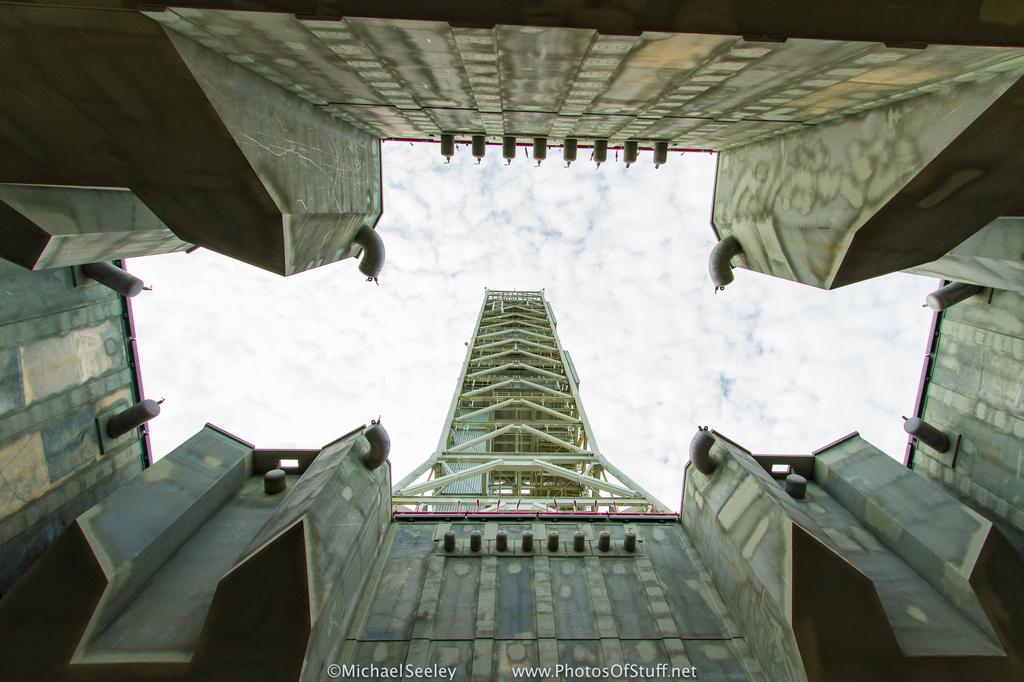What type of buildings can be seen in the image? There are skyscrapers in the image. What structures are present on top of the buildings? There are chimneys in the image. What type of fencing is visible in the image? There are iron grills in the image. What is visible in the background of the image? The sky is visible in the image, and there are clouds in the sky. What type of toy can be seen in the image? There is no toy present in the image. Is there any indication of death or a funeral in the image? There is no indication of death or a funeral in the image. 